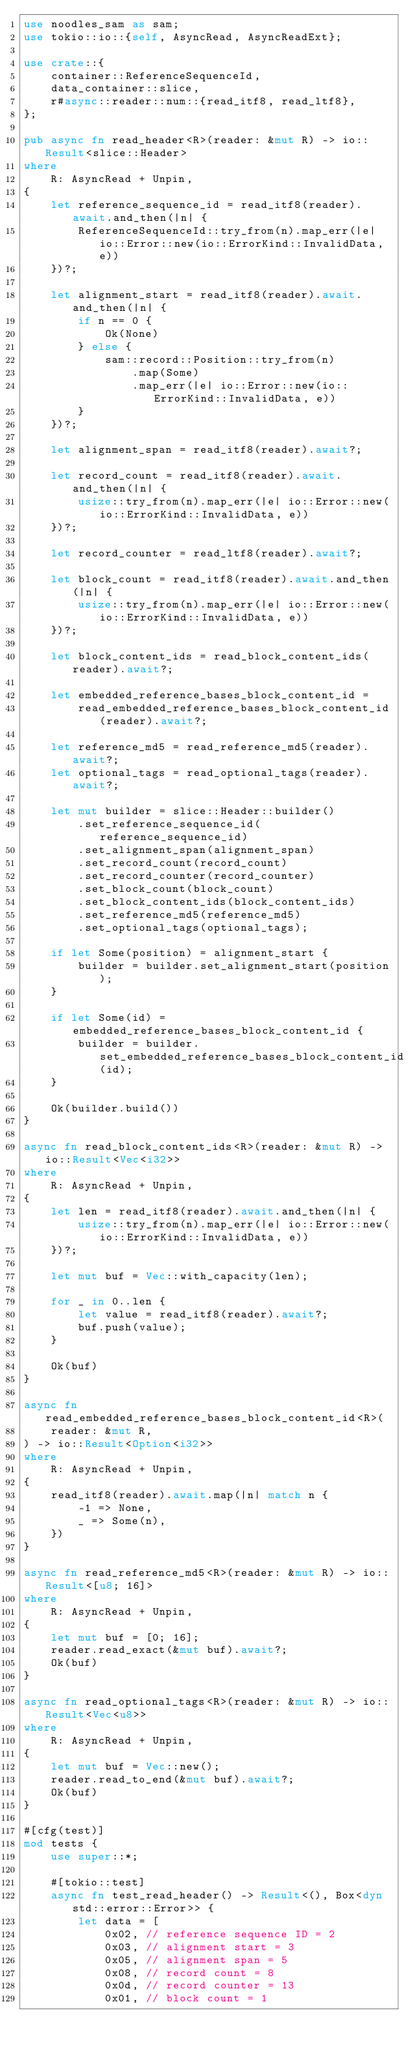<code> <loc_0><loc_0><loc_500><loc_500><_Rust_>use noodles_sam as sam;
use tokio::io::{self, AsyncRead, AsyncReadExt};

use crate::{
    container::ReferenceSequenceId,
    data_container::slice,
    r#async::reader::num::{read_itf8, read_ltf8},
};

pub async fn read_header<R>(reader: &mut R) -> io::Result<slice::Header>
where
    R: AsyncRead + Unpin,
{
    let reference_sequence_id = read_itf8(reader).await.and_then(|n| {
        ReferenceSequenceId::try_from(n).map_err(|e| io::Error::new(io::ErrorKind::InvalidData, e))
    })?;

    let alignment_start = read_itf8(reader).await.and_then(|n| {
        if n == 0 {
            Ok(None)
        } else {
            sam::record::Position::try_from(n)
                .map(Some)
                .map_err(|e| io::Error::new(io::ErrorKind::InvalidData, e))
        }
    })?;

    let alignment_span = read_itf8(reader).await?;

    let record_count = read_itf8(reader).await.and_then(|n| {
        usize::try_from(n).map_err(|e| io::Error::new(io::ErrorKind::InvalidData, e))
    })?;

    let record_counter = read_ltf8(reader).await?;

    let block_count = read_itf8(reader).await.and_then(|n| {
        usize::try_from(n).map_err(|e| io::Error::new(io::ErrorKind::InvalidData, e))
    })?;

    let block_content_ids = read_block_content_ids(reader).await?;

    let embedded_reference_bases_block_content_id =
        read_embedded_reference_bases_block_content_id(reader).await?;

    let reference_md5 = read_reference_md5(reader).await?;
    let optional_tags = read_optional_tags(reader).await?;

    let mut builder = slice::Header::builder()
        .set_reference_sequence_id(reference_sequence_id)
        .set_alignment_span(alignment_span)
        .set_record_count(record_count)
        .set_record_counter(record_counter)
        .set_block_count(block_count)
        .set_block_content_ids(block_content_ids)
        .set_reference_md5(reference_md5)
        .set_optional_tags(optional_tags);

    if let Some(position) = alignment_start {
        builder = builder.set_alignment_start(position);
    }

    if let Some(id) = embedded_reference_bases_block_content_id {
        builder = builder.set_embedded_reference_bases_block_content_id(id);
    }

    Ok(builder.build())
}

async fn read_block_content_ids<R>(reader: &mut R) -> io::Result<Vec<i32>>
where
    R: AsyncRead + Unpin,
{
    let len = read_itf8(reader).await.and_then(|n| {
        usize::try_from(n).map_err(|e| io::Error::new(io::ErrorKind::InvalidData, e))
    })?;

    let mut buf = Vec::with_capacity(len);

    for _ in 0..len {
        let value = read_itf8(reader).await?;
        buf.push(value);
    }

    Ok(buf)
}

async fn read_embedded_reference_bases_block_content_id<R>(
    reader: &mut R,
) -> io::Result<Option<i32>>
where
    R: AsyncRead + Unpin,
{
    read_itf8(reader).await.map(|n| match n {
        -1 => None,
        _ => Some(n),
    })
}

async fn read_reference_md5<R>(reader: &mut R) -> io::Result<[u8; 16]>
where
    R: AsyncRead + Unpin,
{
    let mut buf = [0; 16];
    reader.read_exact(&mut buf).await?;
    Ok(buf)
}

async fn read_optional_tags<R>(reader: &mut R) -> io::Result<Vec<u8>>
where
    R: AsyncRead + Unpin,
{
    let mut buf = Vec::new();
    reader.read_to_end(&mut buf).await?;
    Ok(buf)
}

#[cfg(test)]
mod tests {
    use super::*;

    #[tokio::test]
    async fn test_read_header() -> Result<(), Box<dyn std::error::Error>> {
        let data = [
            0x02, // reference sequence ID = 2
            0x03, // alignment start = 3
            0x05, // alignment span = 5
            0x08, // record count = 8
            0x0d, // record counter = 13
            0x01, // block count = 1</code> 